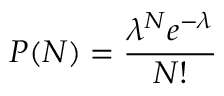Convert formula to latex. <formula><loc_0><loc_0><loc_500><loc_500>P ( N ) = \frac { \lambda ^ { N } e ^ { - \lambda } } { N ! }</formula> 